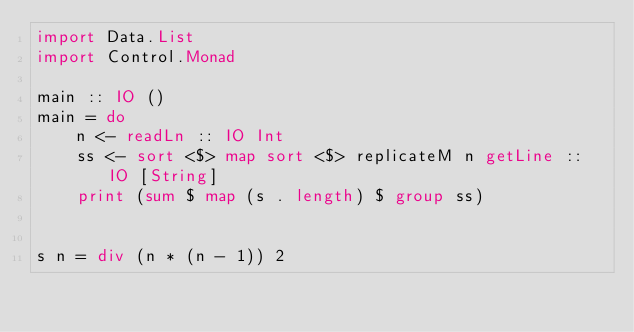<code> <loc_0><loc_0><loc_500><loc_500><_Haskell_>import Data.List
import Control.Monad

main :: IO ()
main = do
    n <- readLn :: IO Int
    ss <- sort <$> map sort <$> replicateM n getLine :: IO [String]
    print (sum $ map (s . length) $ group ss)


s n = div (n * (n - 1)) 2

</code> 